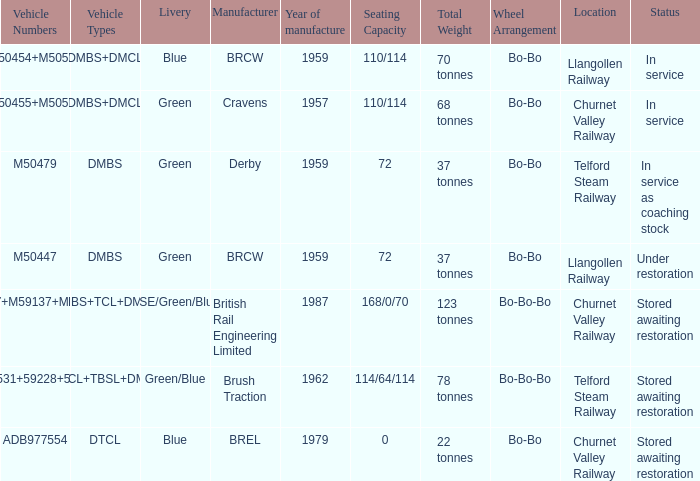What livery has a status of in service as coaching stock? Green. 